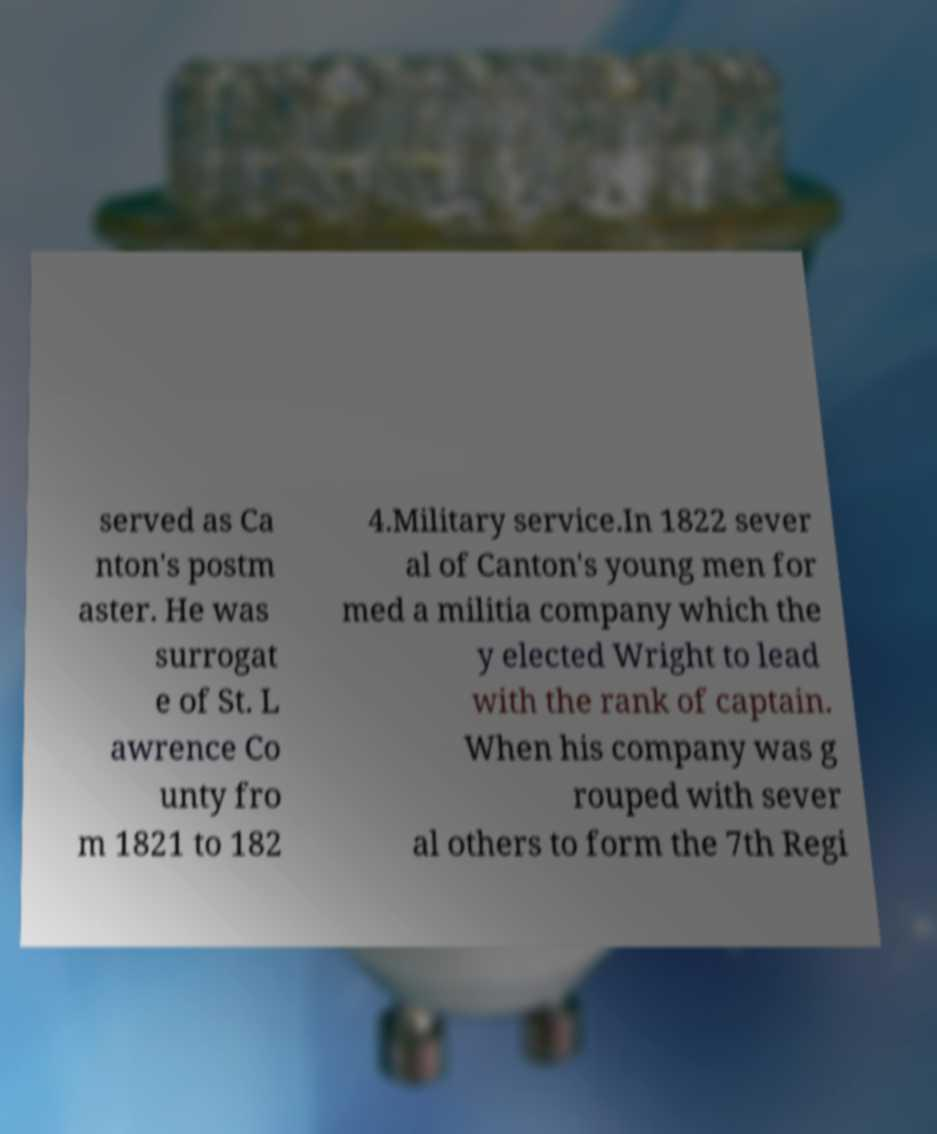What messages or text are displayed in this image? I need them in a readable, typed format. served as Ca nton's postm aster. He was surrogat e of St. L awrence Co unty fro m 1821 to 182 4.Military service.In 1822 sever al of Canton's young men for med a militia company which the y elected Wright to lead with the rank of captain. When his company was g rouped with sever al others to form the 7th Regi 